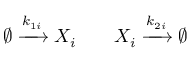<formula> <loc_0><loc_0><loc_500><loc_500>\begin{array} { r l r } { \emptyset \xrightarrow { k _ { 1 i } } X _ { i } } & { X _ { i } \xrightarrow { k _ { 2 i } } \emptyset } \end{array}</formula> 